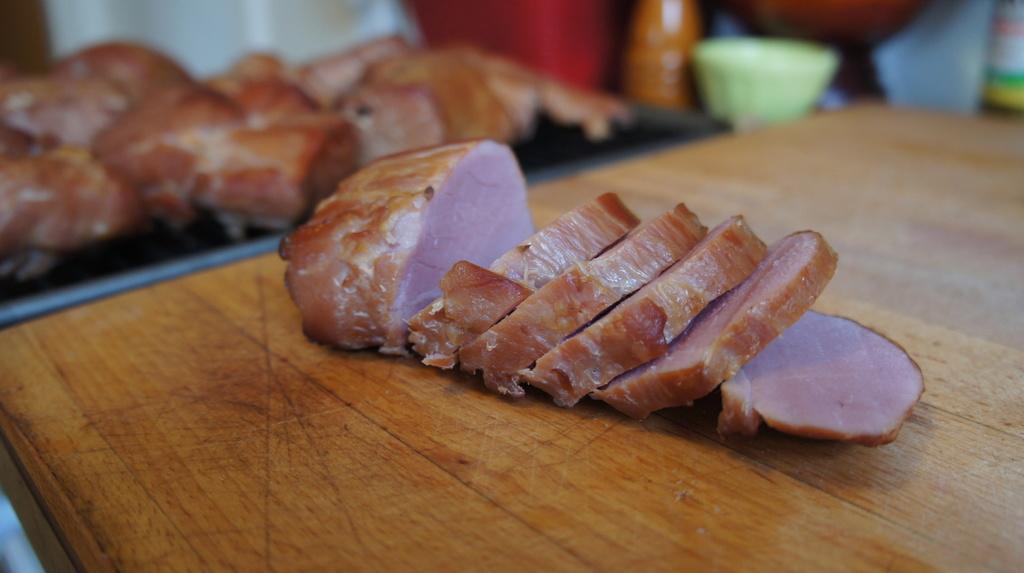Could you give a brief overview of what you see in this image? In this picture we can see a wooden plank, food, bowl and some objects and these all are placed on a platform. 